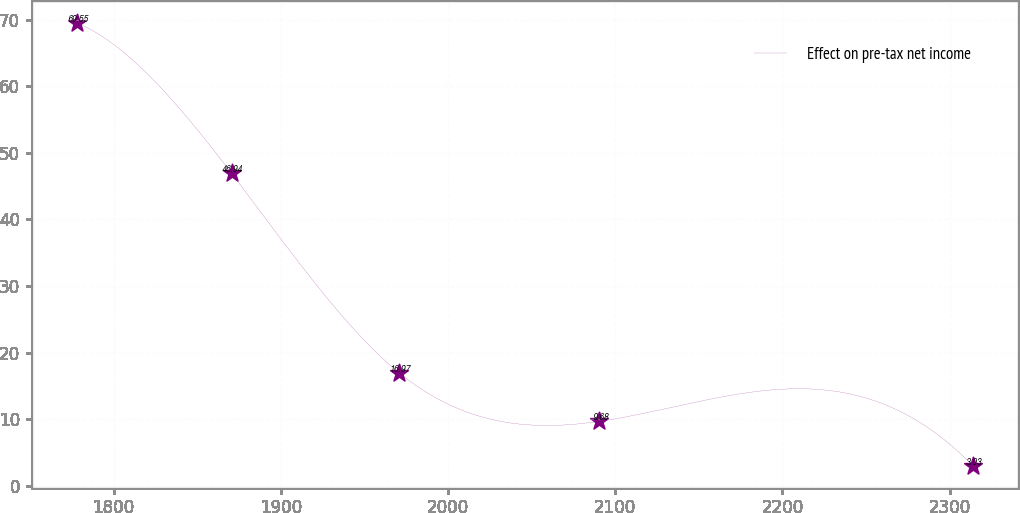Convert chart. <chart><loc_0><loc_0><loc_500><loc_500><line_chart><ecel><fcel>Effect on pre-tax net income<nl><fcel>1777.92<fcel>69.55<nl><fcel>1870.55<fcel>46.94<nl><fcel>1970.75<fcel>16.97<nl><fcel>2090.54<fcel>9.68<nl><fcel>2313.79<fcel>3.03<nl></chart> 